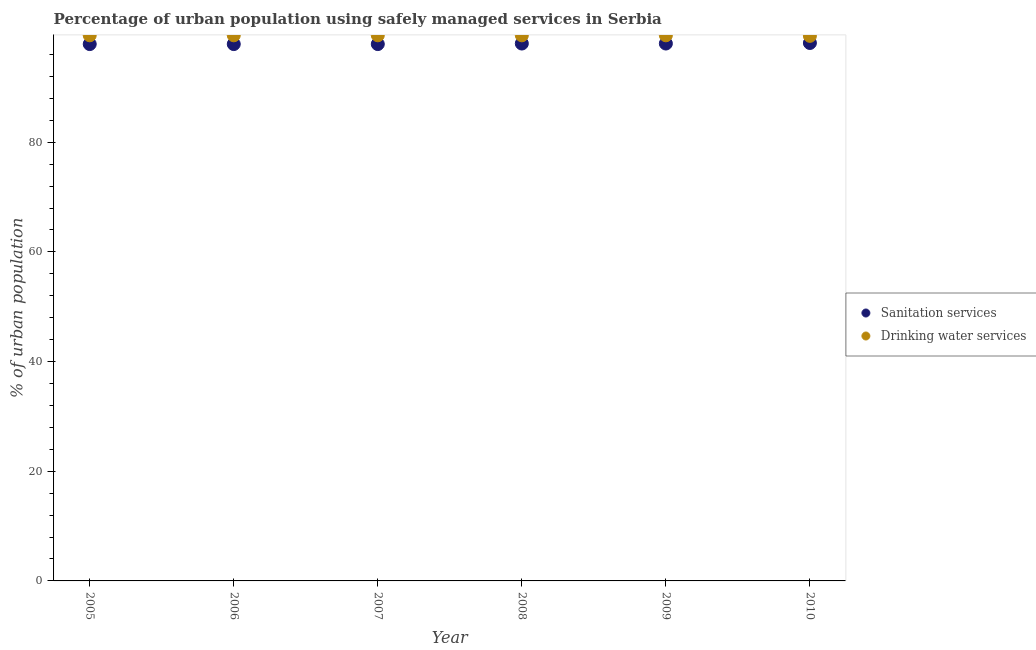What is the percentage of urban population who used sanitation services in 2008?
Keep it short and to the point. 98. Across all years, what is the maximum percentage of urban population who used sanitation services?
Your response must be concise. 98.1. Across all years, what is the minimum percentage of urban population who used drinking water services?
Keep it short and to the point. 99.4. What is the total percentage of urban population who used drinking water services in the graph?
Keep it short and to the point. 596.9. What is the difference between the percentage of urban population who used sanitation services in 2005 and that in 2009?
Give a very brief answer. -0.1. What is the difference between the percentage of urban population who used sanitation services in 2005 and the percentage of urban population who used drinking water services in 2008?
Make the answer very short. -1.6. What is the average percentage of urban population who used sanitation services per year?
Provide a succinct answer. 97.97. In how many years, is the percentage of urban population who used drinking water services greater than 76 %?
Offer a very short reply. 6. Is the percentage of urban population who used drinking water services in 2008 less than that in 2010?
Provide a succinct answer. No. What is the difference between the highest and the second highest percentage of urban population who used drinking water services?
Your response must be concise. 0. What is the difference between the highest and the lowest percentage of urban population who used sanitation services?
Offer a very short reply. 0.2. Does the percentage of urban population who used sanitation services monotonically increase over the years?
Your answer should be compact. No. Is the percentage of urban population who used drinking water services strictly less than the percentage of urban population who used sanitation services over the years?
Your response must be concise. No. How many years are there in the graph?
Offer a terse response. 6. What is the difference between two consecutive major ticks on the Y-axis?
Your answer should be compact. 20. Are the values on the major ticks of Y-axis written in scientific E-notation?
Provide a short and direct response. No. Does the graph contain any zero values?
Make the answer very short. No. How are the legend labels stacked?
Provide a succinct answer. Vertical. What is the title of the graph?
Offer a very short reply. Percentage of urban population using safely managed services in Serbia. What is the label or title of the X-axis?
Give a very brief answer. Year. What is the label or title of the Y-axis?
Ensure brevity in your answer.  % of urban population. What is the % of urban population in Sanitation services in 2005?
Keep it short and to the point. 97.9. What is the % of urban population of Drinking water services in 2005?
Offer a terse response. 99.5. What is the % of urban population of Sanitation services in 2006?
Your response must be concise. 97.9. What is the % of urban population of Drinking water services in 2006?
Offer a very short reply. 99.5. What is the % of urban population in Sanitation services in 2007?
Your answer should be very brief. 97.9. What is the % of urban population in Drinking water services in 2007?
Your answer should be very brief. 99.5. What is the % of urban population in Drinking water services in 2008?
Your answer should be very brief. 99.5. What is the % of urban population in Drinking water services in 2009?
Offer a very short reply. 99.5. What is the % of urban population of Sanitation services in 2010?
Your answer should be compact. 98.1. What is the % of urban population of Drinking water services in 2010?
Your answer should be compact. 99.4. Across all years, what is the maximum % of urban population in Sanitation services?
Provide a succinct answer. 98.1. Across all years, what is the maximum % of urban population of Drinking water services?
Make the answer very short. 99.5. Across all years, what is the minimum % of urban population in Sanitation services?
Your answer should be compact. 97.9. Across all years, what is the minimum % of urban population in Drinking water services?
Offer a very short reply. 99.4. What is the total % of urban population in Sanitation services in the graph?
Make the answer very short. 587.8. What is the total % of urban population of Drinking water services in the graph?
Provide a short and direct response. 596.9. What is the difference between the % of urban population of Sanitation services in 2005 and that in 2006?
Keep it short and to the point. 0. What is the difference between the % of urban population of Drinking water services in 2005 and that in 2006?
Your response must be concise. 0. What is the difference between the % of urban population in Sanitation services in 2005 and that in 2007?
Provide a short and direct response. 0. What is the difference between the % of urban population of Drinking water services in 2005 and that in 2008?
Keep it short and to the point. 0. What is the difference between the % of urban population in Sanitation services in 2005 and that in 2009?
Provide a succinct answer. -0.1. What is the difference between the % of urban population in Sanitation services in 2006 and that in 2007?
Provide a succinct answer. 0. What is the difference between the % of urban population of Sanitation services in 2006 and that in 2008?
Provide a succinct answer. -0.1. What is the difference between the % of urban population of Sanitation services in 2006 and that in 2009?
Your response must be concise. -0.1. What is the difference between the % of urban population in Drinking water services in 2006 and that in 2009?
Offer a terse response. 0. What is the difference between the % of urban population of Sanitation services in 2006 and that in 2010?
Ensure brevity in your answer.  -0.2. What is the difference between the % of urban population of Drinking water services in 2007 and that in 2010?
Offer a terse response. 0.1. What is the difference between the % of urban population in Drinking water services in 2008 and that in 2009?
Ensure brevity in your answer.  0. What is the difference between the % of urban population in Drinking water services in 2008 and that in 2010?
Make the answer very short. 0.1. What is the difference between the % of urban population of Drinking water services in 2009 and that in 2010?
Offer a very short reply. 0.1. What is the difference between the % of urban population in Sanitation services in 2005 and the % of urban population in Drinking water services in 2006?
Offer a terse response. -1.6. What is the difference between the % of urban population of Sanitation services in 2005 and the % of urban population of Drinking water services in 2007?
Offer a terse response. -1.6. What is the difference between the % of urban population of Sanitation services in 2005 and the % of urban population of Drinking water services in 2008?
Your response must be concise. -1.6. What is the difference between the % of urban population in Sanitation services in 2006 and the % of urban population in Drinking water services in 2007?
Give a very brief answer. -1.6. What is the difference between the % of urban population in Sanitation services in 2006 and the % of urban population in Drinking water services in 2008?
Offer a terse response. -1.6. What is the difference between the % of urban population in Sanitation services in 2006 and the % of urban population in Drinking water services in 2009?
Offer a terse response. -1.6. What is the difference between the % of urban population of Sanitation services in 2006 and the % of urban population of Drinking water services in 2010?
Offer a terse response. -1.5. What is the difference between the % of urban population of Sanitation services in 2007 and the % of urban population of Drinking water services in 2010?
Your answer should be very brief. -1.5. What is the difference between the % of urban population of Sanitation services in 2008 and the % of urban population of Drinking water services in 2009?
Ensure brevity in your answer.  -1.5. What is the difference between the % of urban population in Sanitation services in 2008 and the % of urban population in Drinking water services in 2010?
Make the answer very short. -1.4. What is the difference between the % of urban population of Sanitation services in 2009 and the % of urban population of Drinking water services in 2010?
Offer a very short reply. -1.4. What is the average % of urban population of Sanitation services per year?
Provide a succinct answer. 97.97. What is the average % of urban population in Drinking water services per year?
Make the answer very short. 99.48. In the year 2005, what is the difference between the % of urban population of Sanitation services and % of urban population of Drinking water services?
Your answer should be very brief. -1.6. In the year 2006, what is the difference between the % of urban population of Sanitation services and % of urban population of Drinking water services?
Provide a short and direct response. -1.6. In the year 2007, what is the difference between the % of urban population in Sanitation services and % of urban population in Drinking water services?
Make the answer very short. -1.6. In the year 2008, what is the difference between the % of urban population of Sanitation services and % of urban population of Drinking water services?
Make the answer very short. -1.5. In the year 2009, what is the difference between the % of urban population of Sanitation services and % of urban population of Drinking water services?
Provide a succinct answer. -1.5. What is the ratio of the % of urban population in Sanitation services in 2005 to that in 2008?
Provide a short and direct response. 1. What is the ratio of the % of urban population in Sanitation services in 2005 to that in 2009?
Keep it short and to the point. 1. What is the ratio of the % of urban population in Drinking water services in 2005 to that in 2009?
Give a very brief answer. 1. What is the ratio of the % of urban population in Drinking water services in 2005 to that in 2010?
Your response must be concise. 1. What is the ratio of the % of urban population of Drinking water services in 2006 to that in 2007?
Offer a terse response. 1. What is the ratio of the % of urban population in Sanitation services in 2006 to that in 2008?
Ensure brevity in your answer.  1. What is the ratio of the % of urban population in Drinking water services in 2006 to that in 2009?
Offer a very short reply. 1. What is the ratio of the % of urban population in Sanitation services in 2006 to that in 2010?
Your answer should be compact. 1. What is the ratio of the % of urban population in Drinking water services in 2006 to that in 2010?
Offer a terse response. 1. What is the ratio of the % of urban population of Sanitation services in 2007 to that in 2008?
Provide a short and direct response. 1. What is the ratio of the % of urban population of Sanitation services in 2007 to that in 2009?
Provide a short and direct response. 1. What is the ratio of the % of urban population in Drinking water services in 2007 to that in 2009?
Make the answer very short. 1. What is the ratio of the % of urban population in Sanitation services in 2007 to that in 2010?
Offer a very short reply. 1. What is the ratio of the % of urban population of Sanitation services in 2008 to that in 2009?
Provide a short and direct response. 1. What is the ratio of the % of urban population in Drinking water services in 2008 to that in 2009?
Offer a terse response. 1. What is the ratio of the % of urban population in Drinking water services in 2008 to that in 2010?
Offer a very short reply. 1. What is the ratio of the % of urban population in Drinking water services in 2009 to that in 2010?
Your answer should be compact. 1. What is the difference between the highest and the lowest % of urban population of Sanitation services?
Offer a terse response. 0.2. 